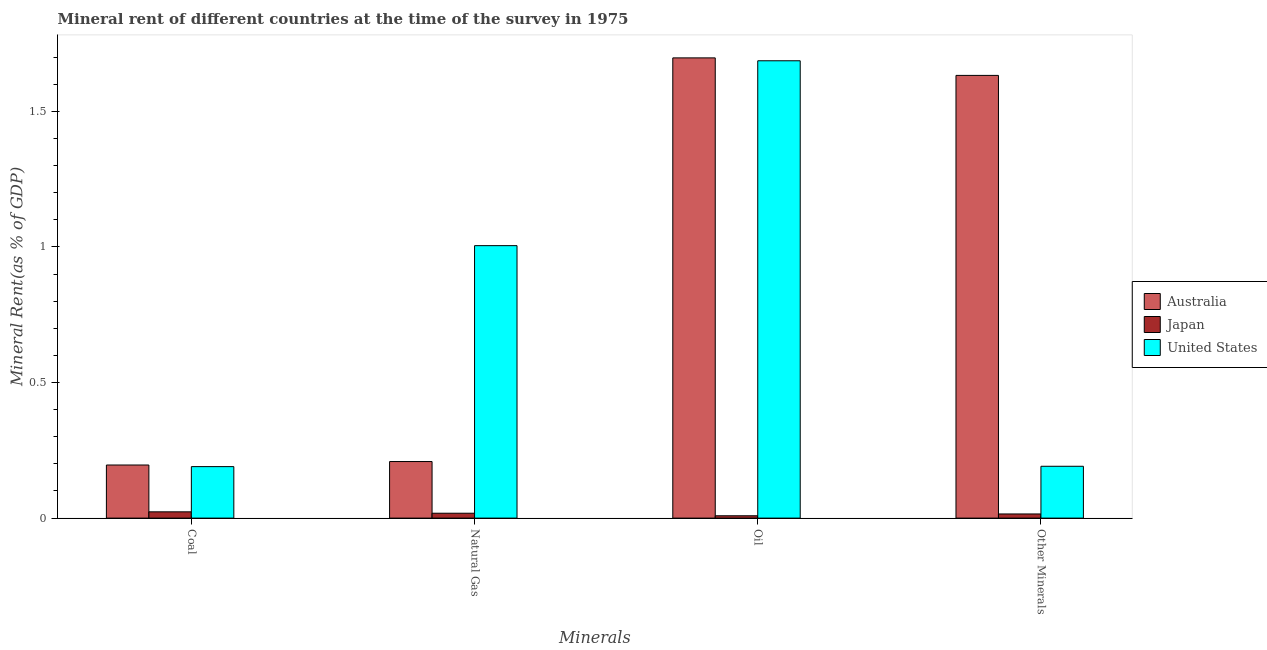How many groups of bars are there?
Make the answer very short. 4. How many bars are there on the 2nd tick from the right?
Offer a very short reply. 3. What is the label of the 4th group of bars from the left?
Your answer should be compact. Other Minerals. What is the oil rent in United States?
Offer a very short reply. 1.69. Across all countries, what is the maximum coal rent?
Ensure brevity in your answer.  0.2. Across all countries, what is the minimum  rent of other minerals?
Provide a short and direct response. 0.02. What is the total natural gas rent in the graph?
Keep it short and to the point. 1.23. What is the difference between the natural gas rent in Japan and that in United States?
Your response must be concise. -0.99. What is the difference between the coal rent in United States and the natural gas rent in Australia?
Your answer should be very brief. -0.02. What is the average coal rent per country?
Provide a short and direct response. 0.14. What is the difference between the coal rent and natural gas rent in Japan?
Ensure brevity in your answer.  0.01. In how many countries, is the oil rent greater than 0.7 %?
Ensure brevity in your answer.  2. What is the ratio of the oil rent in Australia to that in Japan?
Provide a succinct answer. 195.65. Is the difference between the  rent of other minerals in United States and Australia greater than the difference between the coal rent in United States and Australia?
Your answer should be compact. No. What is the difference between the highest and the second highest  rent of other minerals?
Keep it short and to the point. 1.44. What is the difference between the highest and the lowest coal rent?
Your answer should be compact. 0.17. In how many countries, is the oil rent greater than the average oil rent taken over all countries?
Your response must be concise. 2. How many countries are there in the graph?
Your answer should be compact. 3. Does the graph contain any zero values?
Offer a terse response. No. Does the graph contain grids?
Provide a short and direct response. No. How many legend labels are there?
Give a very brief answer. 3. How are the legend labels stacked?
Offer a very short reply. Vertical. What is the title of the graph?
Provide a short and direct response. Mineral rent of different countries at the time of the survey in 1975. What is the label or title of the X-axis?
Offer a terse response. Minerals. What is the label or title of the Y-axis?
Offer a very short reply. Mineral Rent(as % of GDP). What is the Mineral Rent(as % of GDP) of Australia in Coal?
Offer a very short reply. 0.2. What is the Mineral Rent(as % of GDP) of Japan in Coal?
Offer a terse response. 0.02. What is the Mineral Rent(as % of GDP) of United States in Coal?
Provide a succinct answer. 0.19. What is the Mineral Rent(as % of GDP) in Australia in Natural Gas?
Your answer should be very brief. 0.21. What is the Mineral Rent(as % of GDP) in Japan in Natural Gas?
Provide a short and direct response. 0.02. What is the Mineral Rent(as % of GDP) of United States in Natural Gas?
Offer a terse response. 1. What is the Mineral Rent(as % of GDP) in Australia in Oil?
Provide a short and direct response. 1.7. What is the Mineral Rent(as % of GDP) in Japan in Oil?
Give a very brief answer. 0.01. What is the Mineral Rent(as % of GDP) in United States in Oil?
Provide a succinct answer. 1.69. What is the Mineral Rent(as % of GDP) of Australia in Other Minerals?
Your answer should be compact. 1.63. What is the Mineral Rent(as % of GDP) in Japan in Other Minerals?
Your answer should be compact. 0.02. What is the Mineral Rent(as % of GDP) of United States in Other Minerals?
Provide a succinct answer. 0.19. Across all Minerals, what is the maximum Mineral Rent(as % of GDP) of Australia?
Ensure brevity in your answer.  1.7. Across all Minerals, what is the maximum Mineral Rent(as % of GDP) of Japan?
Make the answer very short. 0.02. Across all Minerals, what is the maximum Mineral Rent(as % of GDP) of United States?
Your response must be concise. 1.69. Across all Minerals, what is the minimum Mineral Rent(as % of GDP) in Australia?
Make the answer very short. 0.2. Across all Minerals, what is the minimum Mineral Rent(as % of GDP) in Japan?
Keep it short and to the point. 0.01. Across all Minerals, what is the minimum Mineral Rent(as % of GDP) of United States?
Give a very brief answer. 0.19. What is the total Mineral Rent(as % of GDP) of Australia in the graph?
Keep it short and to the point. 3.73. What is the total Mineral Rent(as % of GDP) in Japan in the graph?
Make the answer very short. 0.07. What is the total Mineral Rent(as % of GDP) in United States in the graph?
Provide a short and direct response. 3.07. What is the difference between the Mineral Rent(as % of GDP) in Australia in Coal and that in Natural Gas?
Keep it short and to the point. -0.01. What is the difference between the Mineral Rent(as % of GDP) of Japan in Coal and that in Natural Gas?
Offer a terse response. 0.01. What is the difference between the Mineral Rent(as % of GDP) of United States in Coal and that in Natural Gas?
Give a very brief answer. -0.81. What is the difference between the Mineral Rent(as % of GDP) of Australia in Coal and that in Oil?
Ensure brevity in your answer.  -1.5. What is the difference between the Mineral Rent(as % of GDP) of Japan in Coal and that in Oil?
Ensure brevity in your answer.  0.01. What is the difference between the Mineral Rent(as % of GDP) in United States in Coal and that in Oil?
Keep it short and to the point. -1.5. What is the difference between the Mineral Rent(as % of GDP) in Australia in Coal and that in Other Minerals?
Your response must be concise. -1.44. What is the difference between the Mineral Rent(as % of GDP) of Japan in Coal and that in Other Minerals?
Your answer should be compact. 0.01. What is the difference between the Mineral Rent(as % of GDP) in United States in Coal and that in Other Minerals?
Give a very brief answer. -0. What is the difference between the Mineral Rent(as % of GDP) in Australia in Natural Gas and that in Oil?
Provide a succinct answer. -1.49. What is the difference between the Mineral Rent(as % of GDP) of Japan in Natural Gas and that in Oil?
Your answer should be compact. 0.01. What is the difference between the Mineral Rent(as % of GDP) of United States in Natural Gas and that in Oil?
Keep it short and to the point. -0.68. What is the difference between the Mineral Rent(as % of GDP) of Australia in Natural Gas and that in Other Minerals?
Give a very brief answer. -1.42. What is the difference between the Mineral Rent(as % of GDP) of Japan in Natural Gas and that in Other Minerals?
Provide a succinct answer. 0. What is the difference between the Mineral Rent(as % of GDP) in United States in Natural Gas and that in Other Minerals?
Provide a succinct answer. 0.81. What is the difference between the Mineral Rent(as % of GDP) of Australia in Oil and that in Other Minerals?
Make the answer very short. 0.06. What is the difference between the Mineral Rent(as % of GDP) in Japan in Oil and that in Other Minerals?
Make the answer very short. -0.01. What is the difference between the Mineral Rent(as % of GDP) of United States in Oil and that in Other Minerals?
Provide a succinct answer. 1.5. What is the difference between the Mineral Rent(as % of GDP) of Australia in Coal and the Mineral Rent(as % of GDP) of Japan in Natural Gas?
Provide a succinct answer. 0.18. What is the difference between the Mineral Rent(as % of GDP) in Australia in Coal and the Mineral Rent(as % of GDP) in United States in Natural Gas?
Your answer should be compact. -0.81. What is the difference between the Mineral Rent(as % of GDP) in Japan in Coal and the Mineral Rent(as % of GDP) in United States in Natural Gas?
Your answer should be very brief. -0.98. What is the difference between the Mineral Rent(as % of GDP) in Australia in Coal and the Mineral Rent(as % of GDP) in Japan in Oil?
Offer a terse response. 0.19. What is the difference between the Mineral Rent(as % of GDP) in Australia in Coal and the Mineral Rent(as % of GDP) in United States in Oil?
Your answer should be very brief. -1.49. What is the difference between the Mineral Rent(as % of GDP) in Japan in Coal and the Mineral Rent(as % of GDP) in United States in Oil?
Your answer should be compact. -1.66. What is the difference between the Mineral Rent(as % of GDP) of Australia in Coal and the Mineral Rent(as % of GDP) of Japan in Other Minerals?
Offer a terse response. 0.18. What is the difference between the Mineral Rent(as % of GDP) of Australia in Coal and the Mineral Rent(as % of GDP) of United States in Other Minerals?
Ensure brevity in your answer.  0. What is the difference between the Mineral Rent(as % of GDP) of Japan in Coal and the Mineral Rent(as % of GDP) of United States in Other Minerals?
Offer a terse response. -0.17. What is the difference between the Mineral Rent(as % of GDP) in Australia in Natural Gas and the Mineral Rent(as % of GDP) in Japan in Oil?
Make the answer very short. 0.2. What is the difference between the Mineral Rent(as % of GDP) in Australia in Natural Gas and the Mineral Rent(as % of GDP) in United States in Oil?
Offer a terse response. -1.48. What is the difference between the Mineral Rent(as % of GDP) in Japan in Natural Gas and the Mineral Rent(as % of GDP) in United States in Oil?
Ensure brevity in your answer.  -1.67. What is the difference between the Mineral Rent(as % of GDP) in Australia in Natural Gas and the Mineral Rent(as % of GDP) in Japan in Other Minerals?
Your response must be concise. 0.19. What is the difference between the Mineral Rent(as % of GDP) of Australia in Natural Gas and the Mineral Rent(as % of GDP) of United States in Other Minerals?
Make the answer very short. 0.02. What is the difference between the Mineral Rent(as % of GDP) in Japan in Natural Gas and the Mineral Rent(as % of GDP) in United States in Other Minerals?
Your response must be concise. -0.17. What is the difference between the Mineral Rent(as % of GDP) of Australia in Oil and the Mineral Rent(as % of GDP) of Japan in Other Minerals?
Offer a terse response. 1.68. What is the difference between the Mineral Rent(as % of GDP) of Australia in Oil and the Mineral Rent(as % of GDP) of United States in Other Minerals?
Provide a succinct answer. 1.51. What is the difference between the Mineral Rent(as % of GDP) in Japan in Oil and the Mineral Rent(as % of GDP) in United States in Other Minerals?
Your answer should be very brief. -0.18. What is the average Mineral Rent(as % of GDP) in Australia per Minerals?
Provide a short and direct response. 0.93. What is the average Mineral Rent(as % of GDP) of Japan per Minerals?
Your response must be concise. 0.02. What is the average Mineral Rent(as % of GDP) of United States per Minerals?
Ensure brevity in your answer.  0.77. What is the difference between the Mineral Rent(as % of GDP) of Australia and Mineral Rent(as % of GDP) of Japan in Coal?
Make the answer very short. 0.17. What is the difference between the Mineral Rent(as % of GDP) in Australia and Mineral Rent(as % of GDP) in United States in Coal?
Your answer should be compact. 0.01. What is the difference between the Mineral Rent(as % of GDP) of Japan and Mineral Rent(as % of GDP) of United States in Coal?
Offer a terse response. -0.17. What is the difference between the Mineral Rent(as % of GDP) in Australia and Mineral Rent(as % of GDP) in Japan in Natural Gas?
Offer a terse response. 0.19. What is the difference between the Mineral Rent(as % of GDP) of Australia and Mineral Rent(as % of GDP) of United States in Natural Gas?
Offer a terse response. -0.8. What is the difference between the Mineral Rent(as % of GDP) in Japan and Mineral Rent(as % of GDP) in United States in Natural Gas?
Your answer should be very brief. -0.99. What is the difference between the Mineral Rent(as % of GDP) of Australia and Mineral Rent(as % of GDP) of Japan in Oil?
Ensure brevity in your answer.  1.69. What is the difference between the Mineral Rent(as % of GDP) of Australia and Mineral Rent(as % of GDP) of United States in Oil?
Offer a very short reply. 0.01. What is the difference between the Mineral Rent(as % of GDP) in Japan and Mineral Rent(as % of GDP) in United States in Oil?
Keep it short and to the point. -1.68. What is the difference between the Mineral Rent(as % of GDP) of Australia and Mineral Rent(as % of GDP) of Japan in Other Minerals?
Your answer should be compact. 1.62. What is the difference between the Mineral Rent(as % of GDP) of Australia and Mineral Rent(as % of GDP) of United States in Other Minerals?
Make the answer very short. 1.44. What is the difference between the Mineral Rent(as % of GDP) in Japan and Mineral Rent(as % of GDP) in United States in Other Minerals?
Your answer should be compact. -0.18. What is the ratio of the Mineral Rent(as % of GDP) in Australia in Coal to that in Natural Gas?
Offer a very short reply. 0.94. What is the ratio of the Mineral Rent(as % of GDP) in Japan in Coal to that in Natural Gas?
Make the answer very short. 1.28. What is the ratio of the Mineral Rent(as % of GDP) of United States in Coal to that in Natural Gas?
Make the answer very short. 0.19. What is the ratio of the Mineral Rent(as % of GDP) in Australia in Coal to that in Oil?
Ensure brevity in your answer.  0.12. What is the ratio of the Mineral Rent(as % of GDP) of Japan in Coal to that in Oil?
Provide a succinct answer. 2.67. What is the ratio of the Mineral Rent(as % of GDP) in United States in Coal to that in Oil?
Provide a succinct answer. 0.11. What is the ratio of the Mineral Rent(as % of GDP) of Australia in Coal to that in Other Minerals?
Offer a very short reply. 0.12. What is the ratio of the Mineral Rent(as % of GDP) of Japan in Coal to that in Other Minerals?
Your answer should be very brief. 1.51. What is the ratio of the Mineral Rent(as % of GDP) in Australia in Natural Gas to that in Oil?
Make the answer very short. 0.12. What is the ratio of the Mineral Rent(as % of GDP) in Japan in Natural Gas to that in Oil?
Provide a short and direct response. 2.08. What is the ratio of the Mineral Rent(as % of GDP) in United States in Natural Gas to that in Oil?
Offer a very short reply. 0.6. What is the ratio of the Mineral Rent(as % of GDP) of Australia in Natural Gas to that in Other Minerals?
Keep it short and to the point. 0.13. What is the ratio of the Mineral Rent(as % of GDP) of Japan in Natural Gas to that in Other Minerals?
Provide a succinct answer. 1.18. What is the ratio of the Mineral Rent(as % of GDP) of United States in Natural Gas to that in Other Minerals?
Ensure brevity in your answer.  5.26. What is the ratio of the Mineral Rent(as % of GDP) of Australia in Oil to that in Other Minerals?
Offer a terse response. 1.04. What is the ratio of the Mineral Rent(as % of GDP) in Japan in Oil to that in Other Minerals?
Your response must be concise. 0.57. What is the ratio of the Mineral Rent(as % of GDP) of United States in Oil to that in Other Minerals?
Give a very brief answer. 8.82. What is the difference between the highest and the second highest Mineral Rent(as % of GDP) of Australia?
Offer a very short reply. 0.06. What is the difference between the highest and the second highest Mineral Rent(as % of GDP) of Japan?
Your answer should be very brief. 0.01. What is the difference between the highest and the second highest Mineral Rent(as % of GDP) of United States?
Make the answer very short. 0.68. What is the difference between the highest and the lowest Mineral Rent(as % of GDP) of Australia?
Keep it short and to the point. 1.5. What is the difference between the highest and the lowest Mineral Rent(as % of GDP) of Japan?
Ensure brevity in your answer.  0.01. What is the difference between the highest and the lowest Mineral Rent(as % of GDP) in United States?
Give a very brief answer. 1.5. 